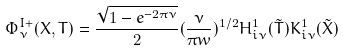<formula> <loc_0><loc_0><loc_500><loc_500>\Phi _ { \nu } ^ { I + } ( X , T ) = \frac { \sqrt { 1 - e ^ { - 2 \pi \nu } } } { 2 } ( \frac { \nu } { \pi w } ) ^ { 1 / 2 } H _ { i \nu } ^ { 1 } ( \tilde { T } ) K _ { i \nu } ^ { 1 } ( \tilde { X } )</formula> 